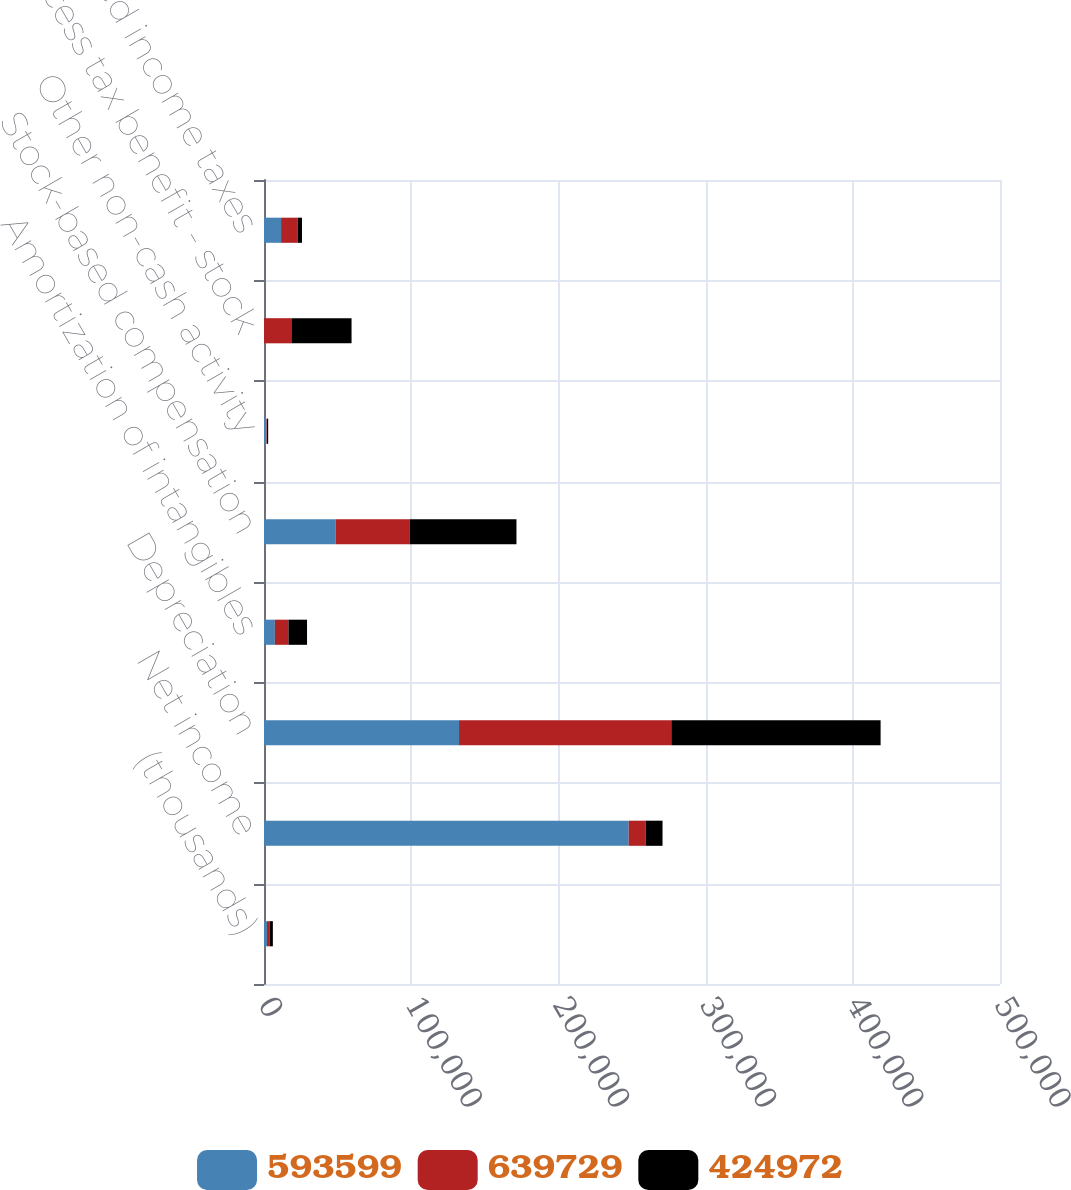Convert chart to OTSL. <chart><loc_0><loc_0><loc_500><loc_500><stacked_bar_chart><ecel><fcel>(thousands)<fcel>Net income<fcel>Depreciation<fcel>Amortization of intangibles<fcel>Stock-based compensation<fcel>Other non-cash activity<fcel>Excess tax benefit - stock<fcel>Deferred income taxes<nl><fcel>593599<fcel>2009<fcel>247772<fcel>132493<fcel>7377<fcel>48613<fcel>1663<fcel>20<fcel>11595<nl><fcel>639729<fcel>2008<fcel>11482<fcel>144222<fcel>9250<fcel>50247<fcel>310<fcel>18586<fcel>11369<nl><fcel>424972<fcel>2007<fcel>11482<fcel>142173<fcel>12610<fcel>72652<fcel>853<fcel>40871<fcel>2850<nl></chart> 